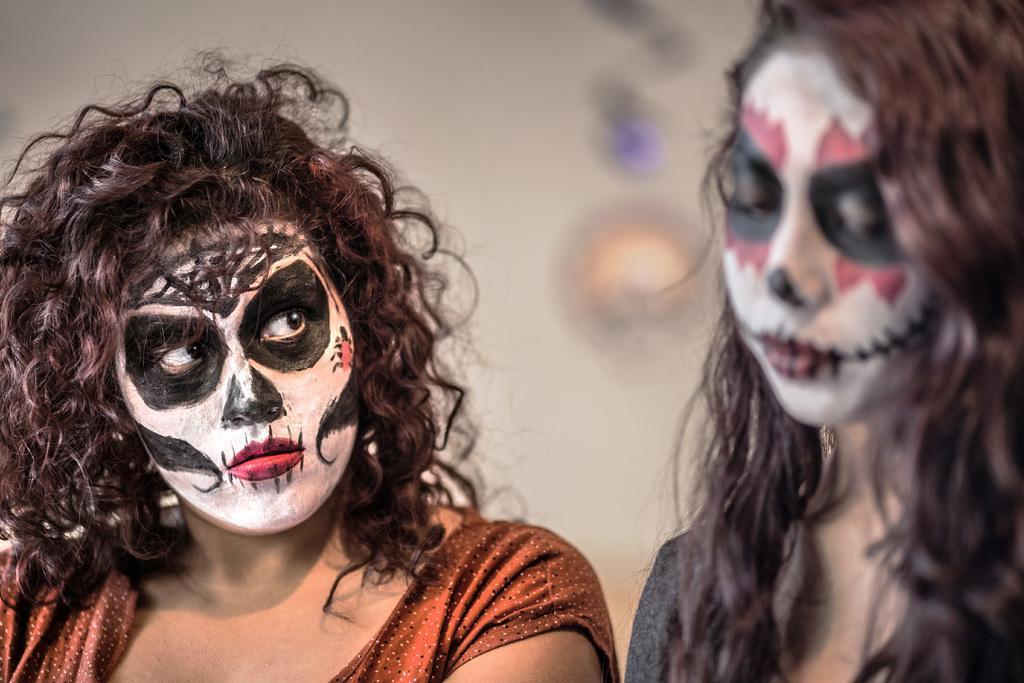Could you give a brief overview of what you see in this image? In the picture we can see a two woman are with different costumes to their faces and behind them we can see a wall with a light. 